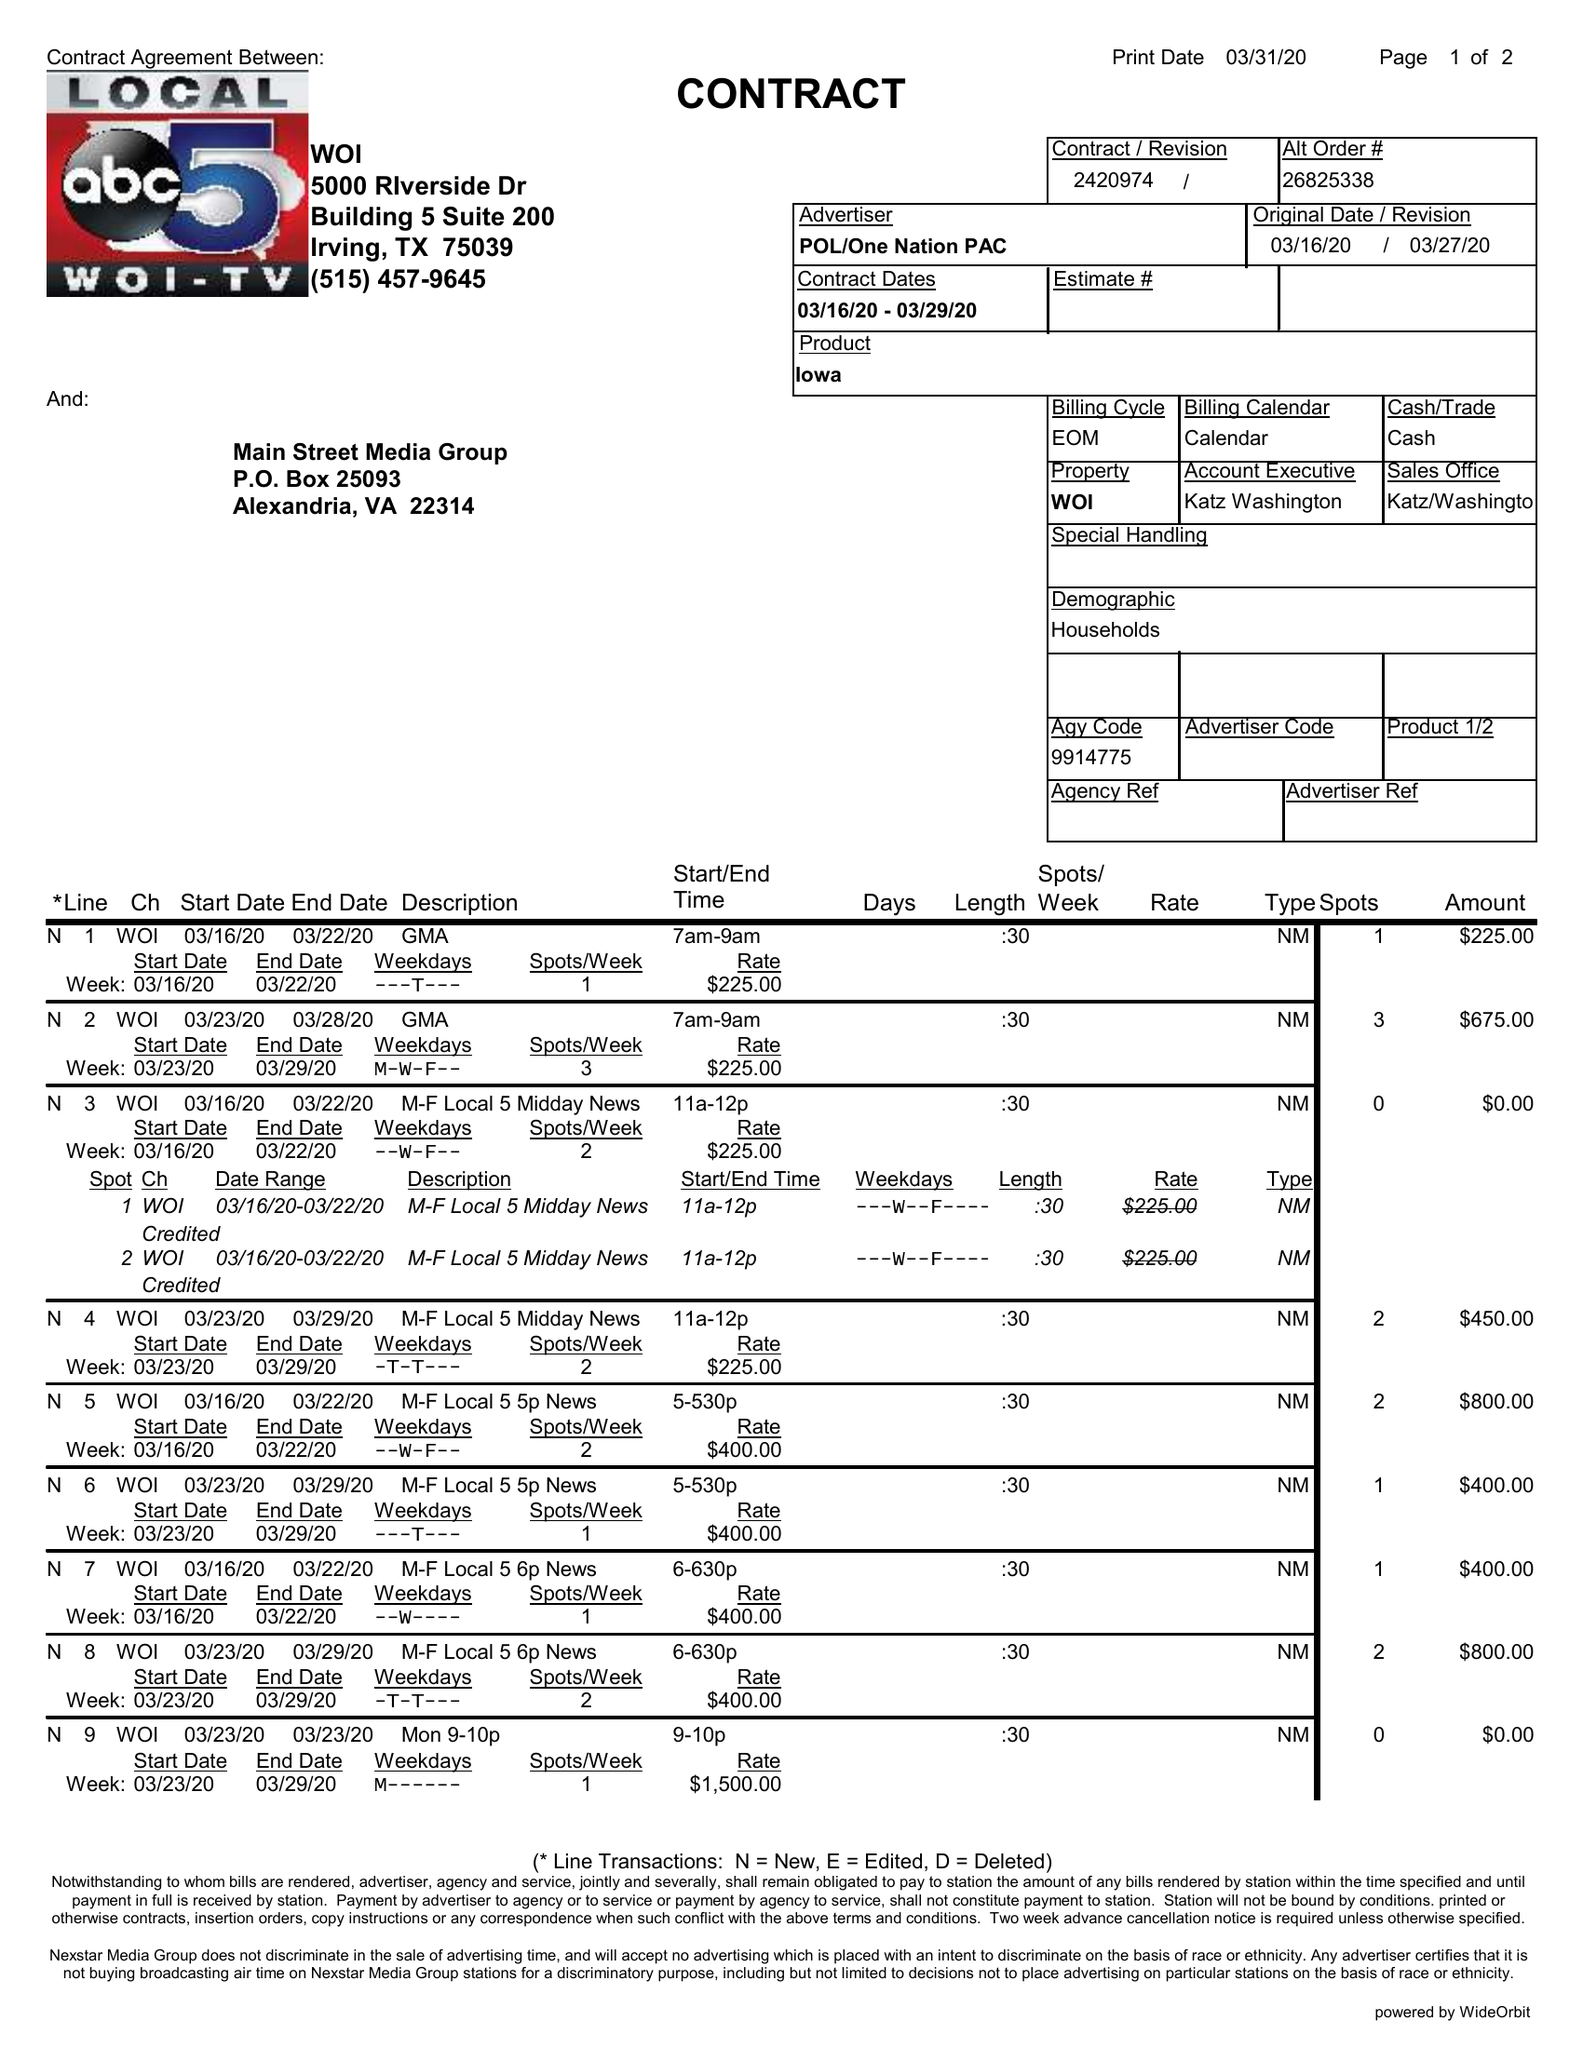What is the value for the advertiser?
Answer the question using a single word or phrase. POL/ONENATIONPAC 